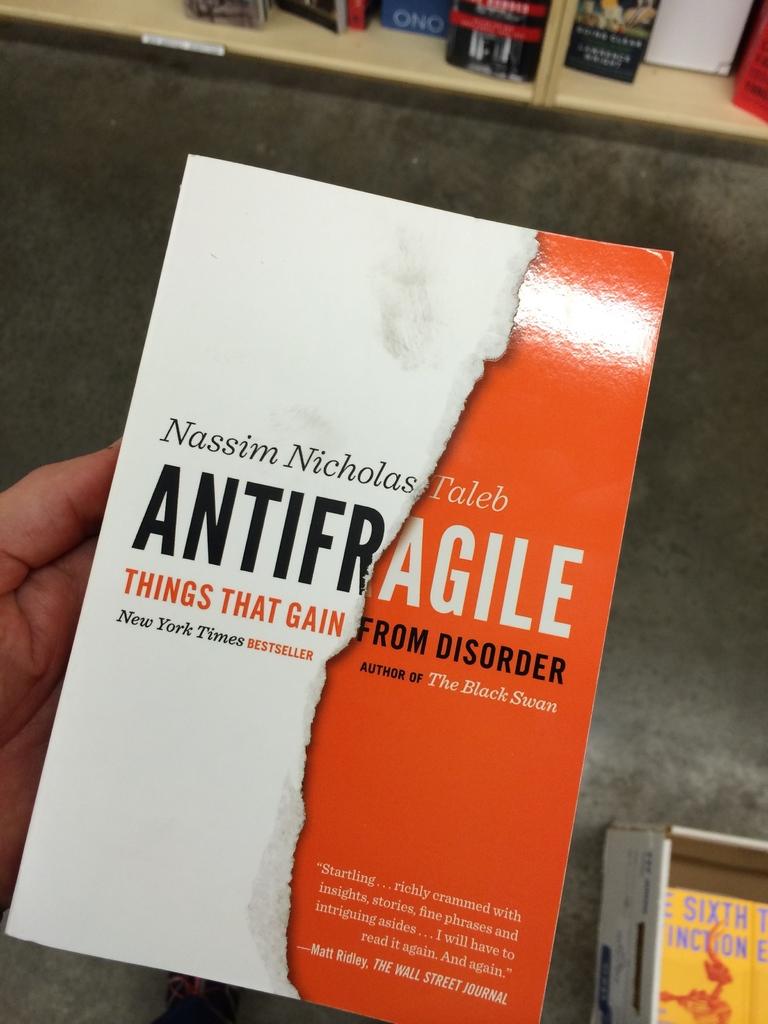What other book has taleb written?
Provide a short and direct response. The black swan. What´s the tittle of this book?
Your answer should be compact. Antifragile. 